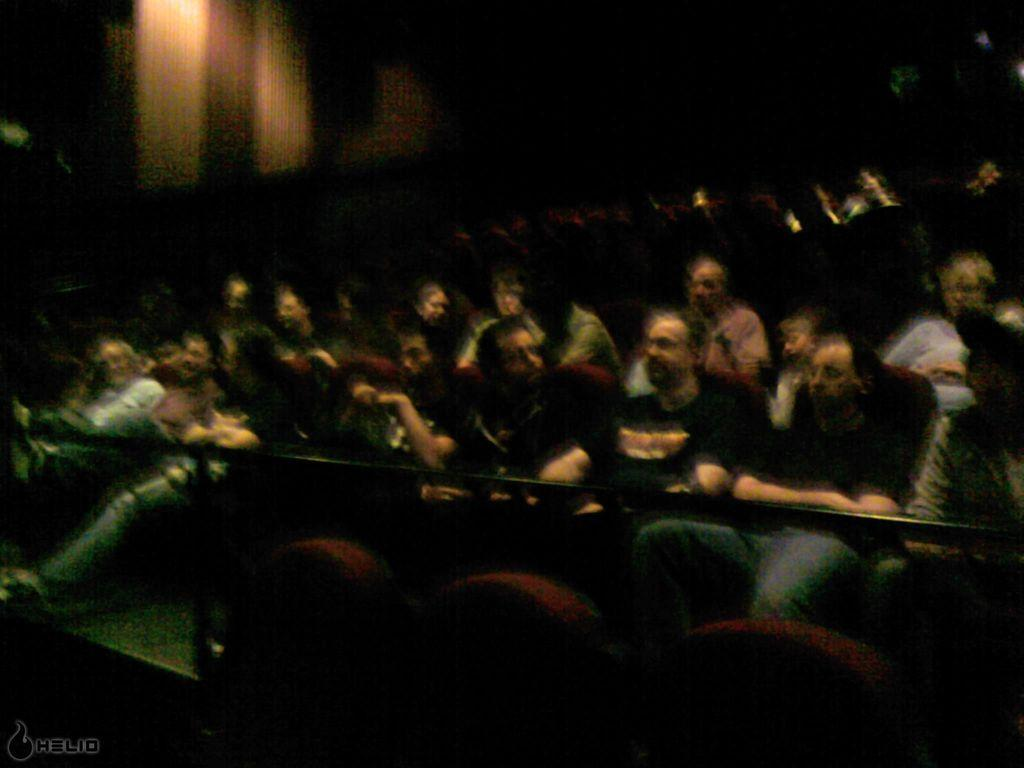What are the people in the image doing? The people in the image are sitting on chairs. What is in front of the people? There is a railing in front of the people. How would you describe the background of the image? The background of the image is dark. What type of stove can be seen in the image? There is no stove present in the image. How many dolls are sitting on the chairs with the people? There are no dolls present in the image; only people are sitting on the chairs. 